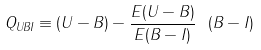Convert formula to latex. <formula><loc_0><loc_0><loc_500><loc_500>Q _ { U B I } \equiv ( U - B ) - \frac { E ( U - B ) } { E ( B - I ) } \ ( B - I )</formula> 